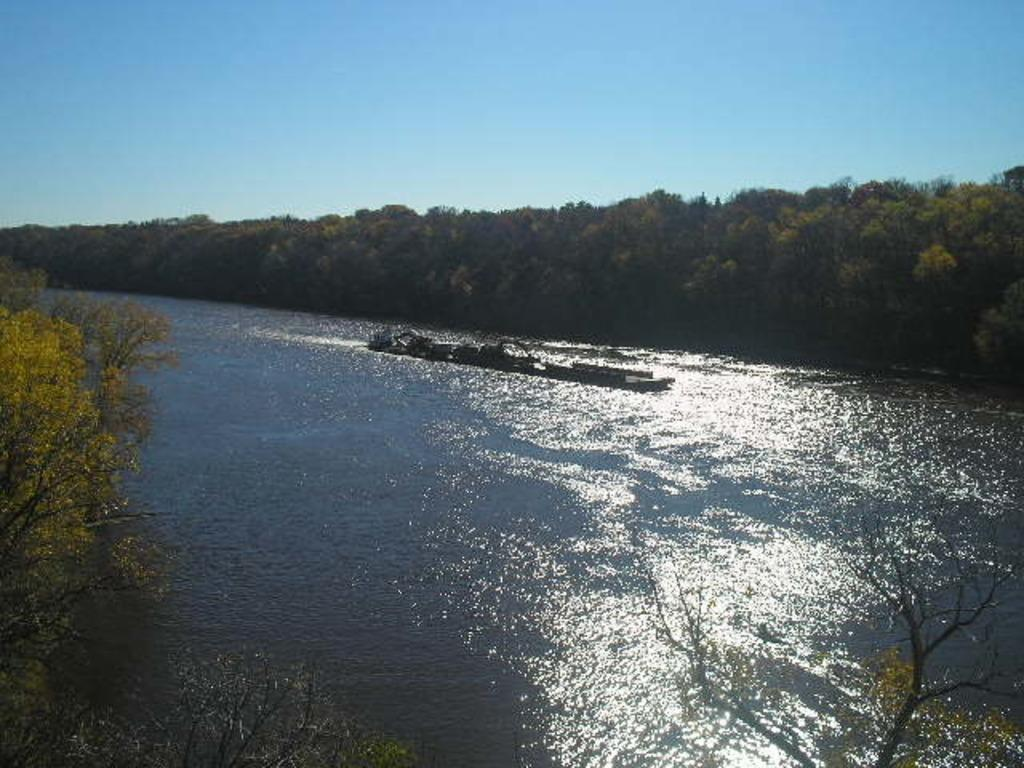What type of vegetation is present at the bottom of the image? There are trees at the bottom of the image. What can be seen alongside the trees at the bottom of the image? There is water visible at the bottom of the image. What is floating on the water in the image? There is a boat on the water. What is visible in the background of the image? There are trees and the sky visible in the background of the image. Where is the hospital located in the image? There is no hospital present in the image. Is the queen attending a ceremony in the image? There is no queen or ceremony depicted in the image. 